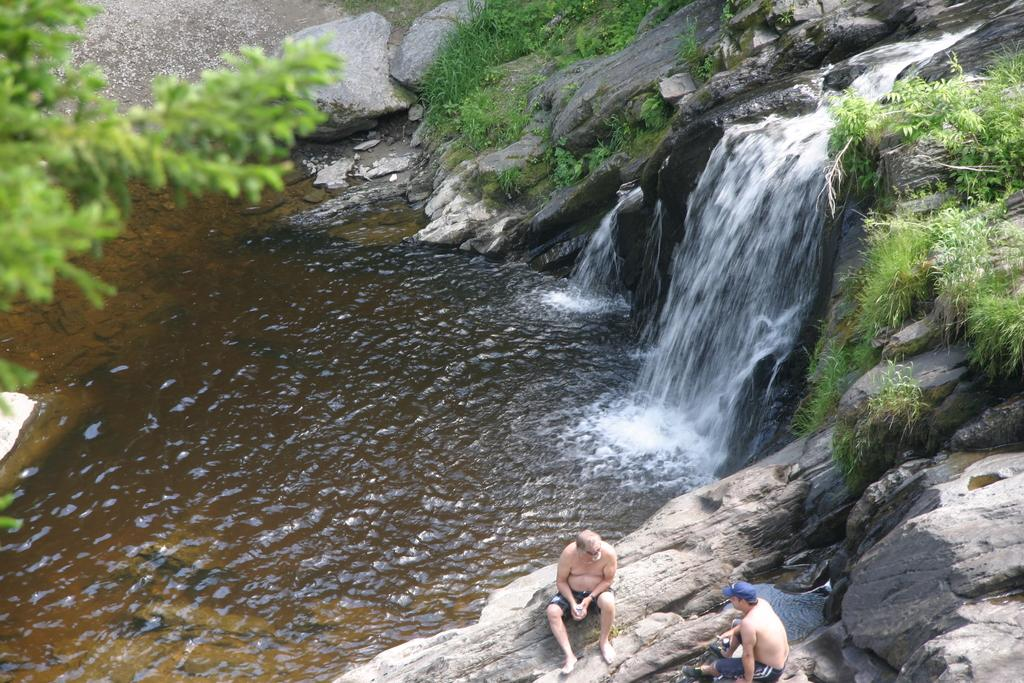How many people are sitting in the image? There are two persons sitting in the image. What can be seen in the background of the image? Water, plants, and trees are visible in the background of the image. What is the color of the plants and trees in the image? The plants and trees are green in color. What type of cheese is being used to patch the hole in the image? There is no cheese or hole present in the image. 